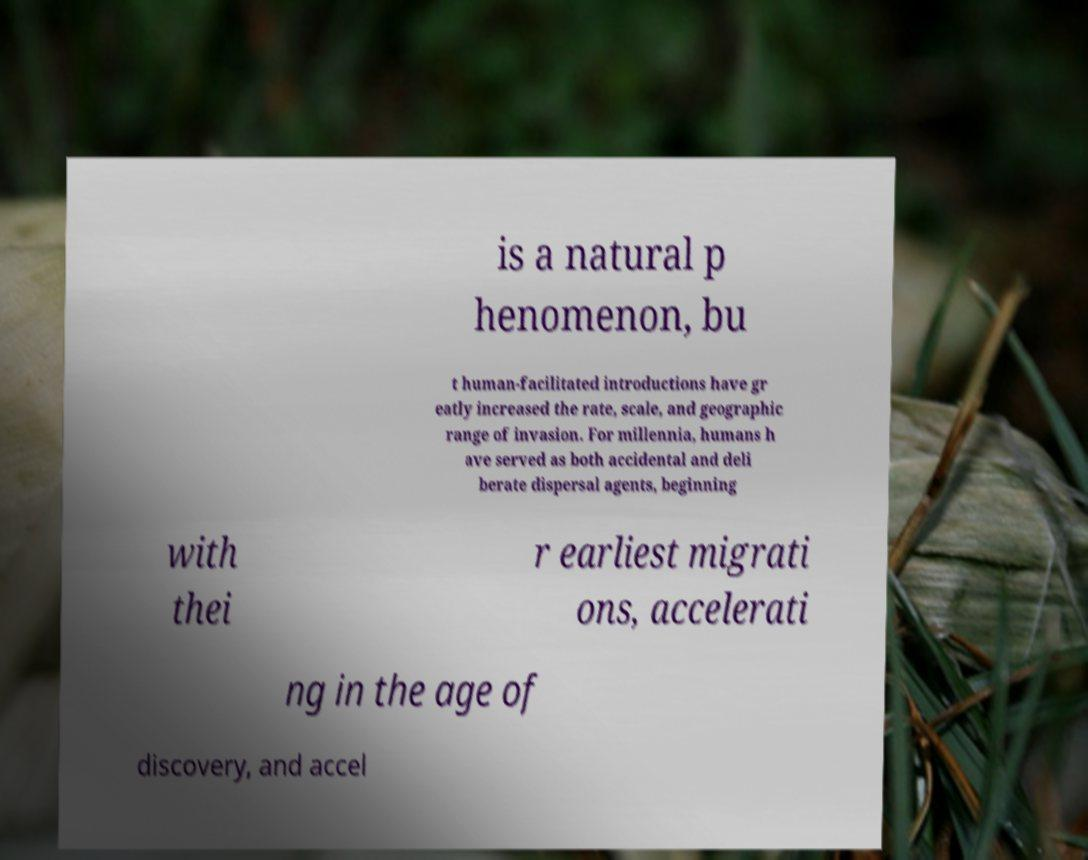Please identify and transcribe the text found in this image. is a natural p henomenon, bu t human-facilitated introductions have gr eatly increased the rate, scale, and geographic range of invasion. For millennia, humans h ave served as both accidental and deli berate dispersal agents, beginning with thei r earliest migrati ons, accelerati ng in the age of discovery, and accel 